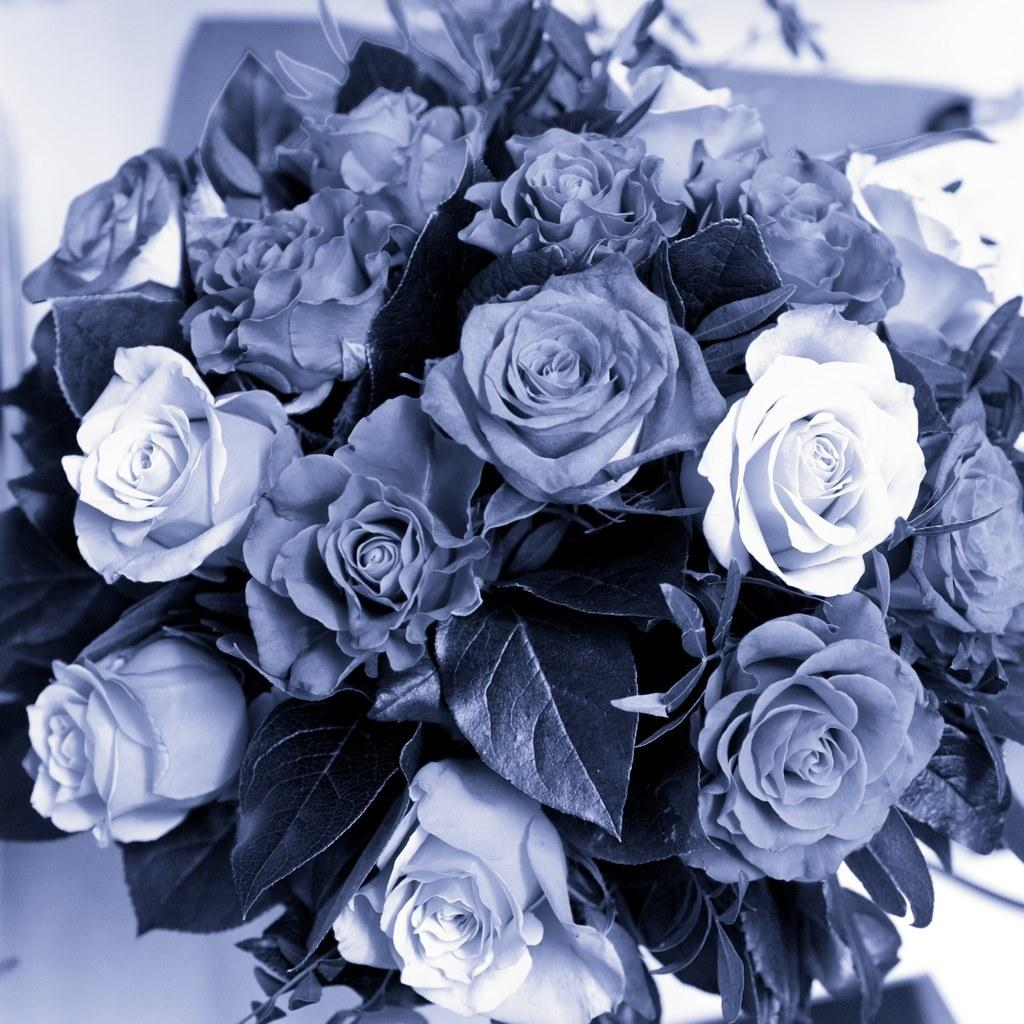What type of flowers are present in the image? There are rose flowers in the image. What else can be seen in the image besides the flowers? There are leaves in the image. What type of band is playing music in the image? There is no band present in the image; it only features rose flowers and leaves. 